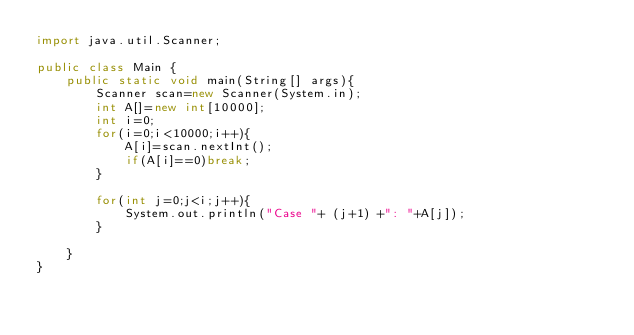<code> <loc_0><loc_0><loc_500><loc_500><_Java_>import java.util.Scanner;

public class Main {
	public static void main(String[] args){
		Scanner scan=new Scanner(System.in);
		int A[]=new int[10000];
        int i=0;
		for(i=0;i<10000;i++){
			A[i]=scan.nextInt();
		    if(A[i]==0)break;
		}

		for(int j=0;j<i;j++){
			System.out.println("Case "+ (j+1) +": "+A[j]);
		}
		
	}
}
</code> 